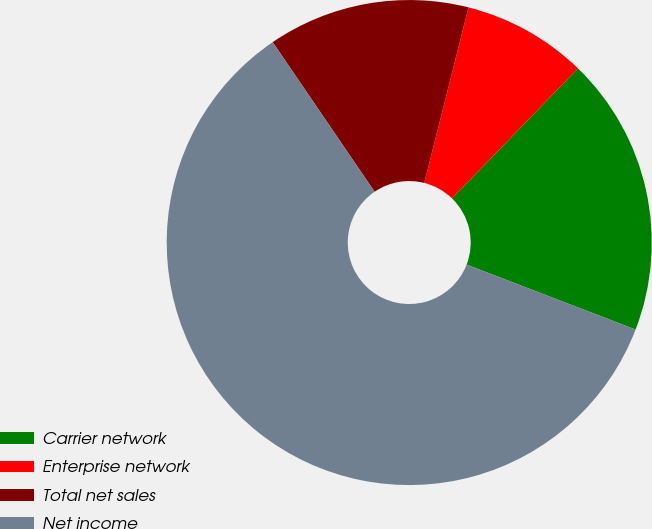<chart> <loc_0><loc_0><loc_500><loc_500><pie_chart><fcel>Carrier network<fcel>Enterprise network<fcel>Total net sales<fcel>Net income<nl><fcel>18.59%<fcel>8.32%<fcel>13.45%<fcel>59.64%<nl></chart> 